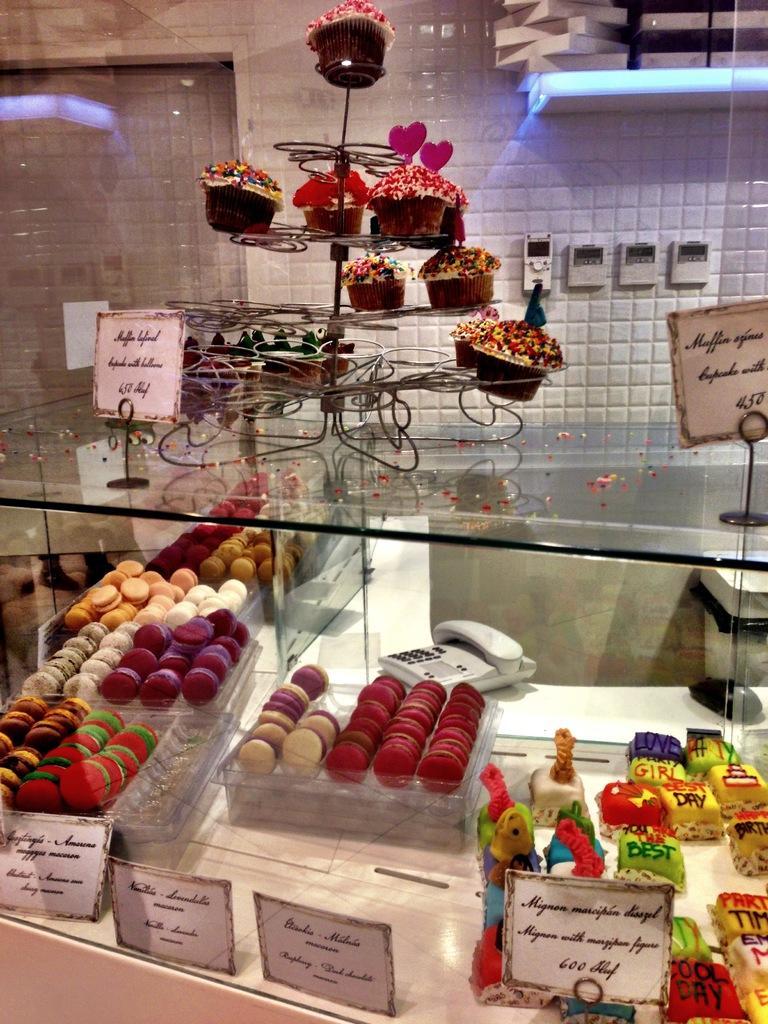How would you summarize this image in a sentence or two? In this image we can see a cupcake, and sprinkles on it, here is the name board on the table, here is the food item, here is the telephone, here is the wall. 